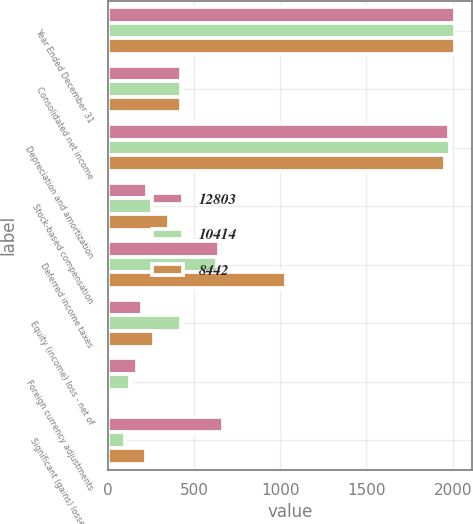<chart> <loc_0><loc_0><loc_500><loc_500><stacked_bar_chart><ecel><fcel>Year Ended December 31<fcel>Consolidated net income<fcel>Depreciation and amortization<fcel>Stock-based compensation<fcel>Deferred income taxes<fcel>Equity (income) loss - net of<fcel>Foreign currency adjustments<fcel>Significant (gains) losses on<nl><fcel>12803<fcel>2013<fcel>426<fcel>1977<fcel>227<fcel>648<fcel>201<fcel>168<fcel>670<nl><fcel>10414<fcel>2012<fcel>426<fcel>1982<fcel>259<fcel>632<fcel>426<fcel>130<fcel>98<nl><fcel>8442<fcel>2011<fcel>426<fcel>1954<fcel>354<fcel>1035<fcel>269<fcel>7<fcel>220<nl></chart> 